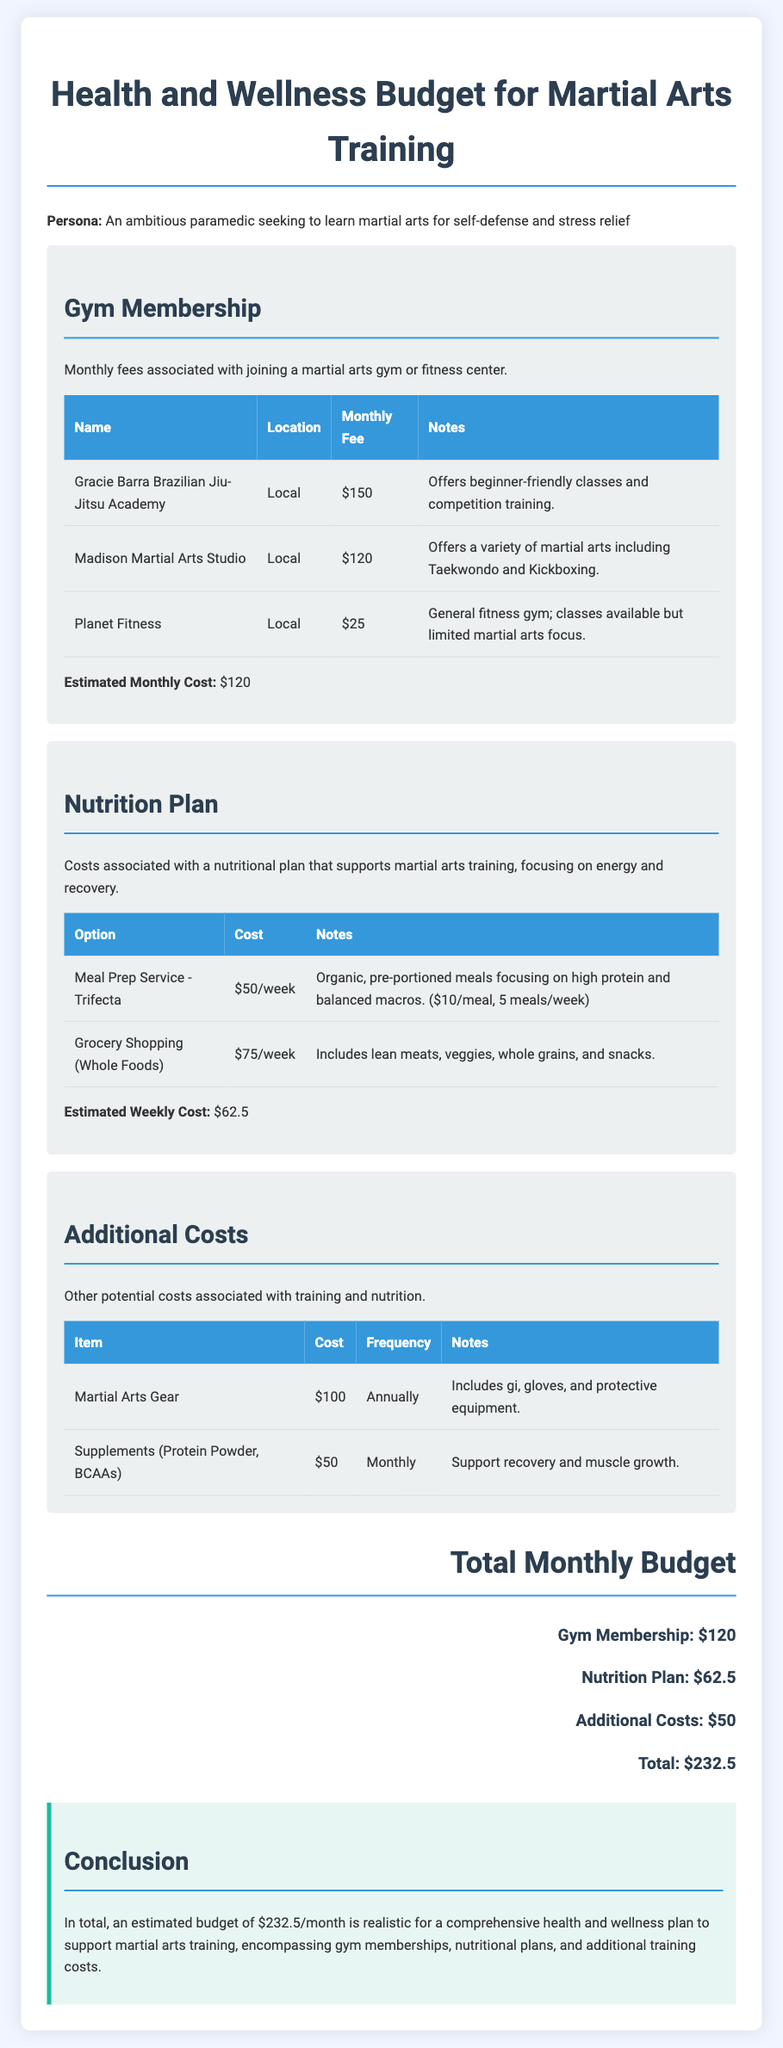what is the monthly fee for Gracie Barra Brazilian Jiu-Jitsu Academy? The fee for Gracie Barra Brazilian Jiu-Jitsu Academy is stated in the gym membership section of the document.
Answer: $150 what is the estimated weekly cost for the nutrition plan? The document lists the estimated weekly cost for the nutrition plan under the Nutrition Plan section.
Answer: $62.5 how much does martial arts gear cost annually? The cost is mentioned in the Additional Costs section, which details annual expenses.
Answer: $100 what is the total monthly budget? The total monthly budget is calculated based on gym membership, nutrition plan, and additional costs summarized at the end.
Answer: $232.5 which gym offers competition training? The document specifies that Gracie Barra Brazilian Jiu-Jitsu Academy offers competition training in its notes.
Answer: Gracie Barra Brazilian Jiu-Jitsu Academy what type of meals does the meal prep service provide? The document notes that the meal prep service focuses on organic, pre-portioned meals with high protein and balanced macros.
Answer: Organic, pre-portioned meals how frequently should supplements be purchased? The frequency of purchasing supplements is detailed in the Additional Costs table.
Answer: Monthly which nutrition option is more expensive, meal prep service or grocery shopping? Comparison can be made by examining the costs listed in the Nutrition Plan section of the document.
Answer: Grocery Shopping (Whole Foods) what is the monthly cost for supplements? The monthly cost for supplements is indicated in the Additional Costs section.
Answer: $50 